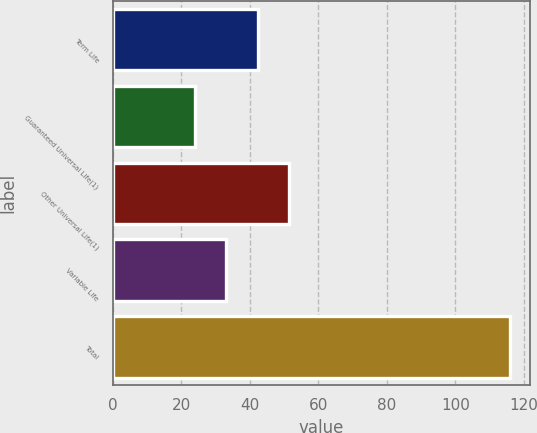Convert chart to OTSL. <chart><loc_0><loc_0><loc_500><loc_500><bar_chart><fcel>Term Life<fcel>Guaranteed Universal Life(1)<fcel>Other Universal Life(1)<fcel>Variable Life<fcel>Total<nl><fcel>42.4<fcel>24<fcel>51.6<fcel>33.2<fcel>116<nl></chart> 